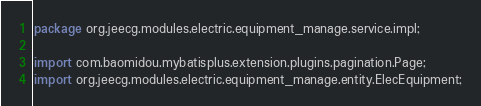Convert code to text. <code><loc_0><loc_0><loc_500><loc_500><_Java_>package org.jeecg.modules.electric.equipment_manage.service.impl;

import com.baomidou.mybatisplus.extension.plugins.pagination.Page;
import org.jeecg.modules.electric.equipment_manage.entity.ElecEquipment;</code> 